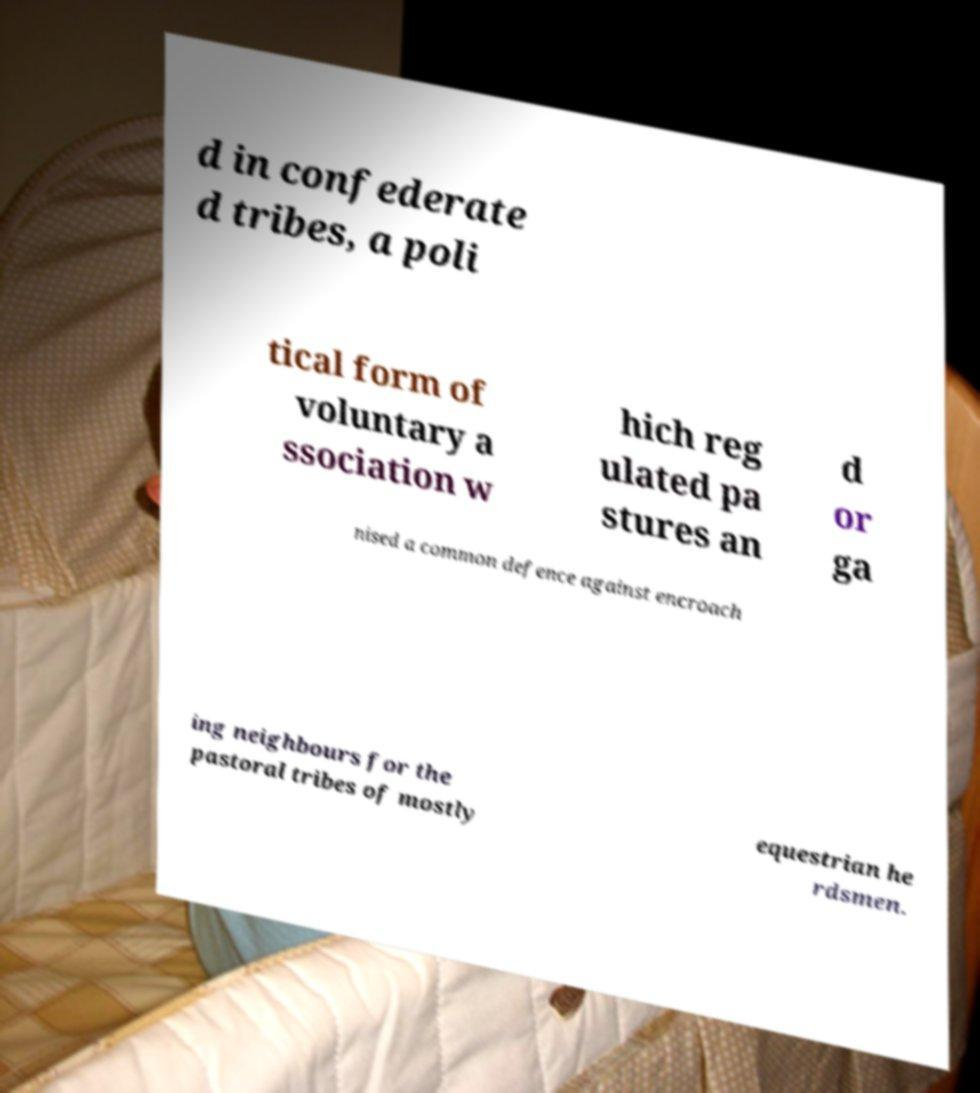Please read and relay the text visible in this image. What does it say? d in confederate d tribes, a poli tical form of voluntary a ssociation w hich reg ulated pa stures an d or ga nised a common defence against encroach ing neighbours for the pastoral tribes of mostly equestrian he rdsmen. 